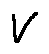Convert formula to latex. <formula><loc_0><loc_0><loc_500><loc_500>V</formula> 